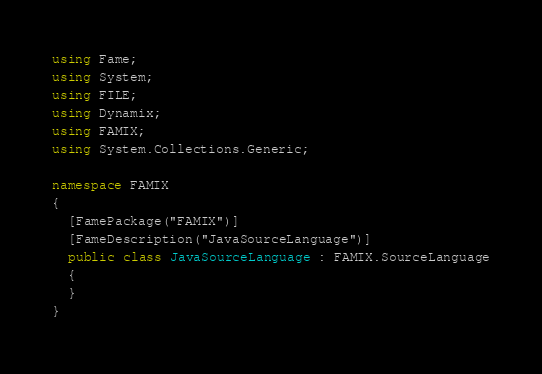<code> <loc_0><loc_0><loc_500><loc_500><_C#_>using Fame;
using System;
using FILE;
using Dynamix;
using FAMIX;
using System.Collections.Generic;

namespace FAMIX
{
  [FamePackage("FAMIX")]
  [FameDescription("JavaSourceLanguage")]
  public class JavaSourceLanguage : FAMIX.SourceLanguage
  {
  }
}
</code> 